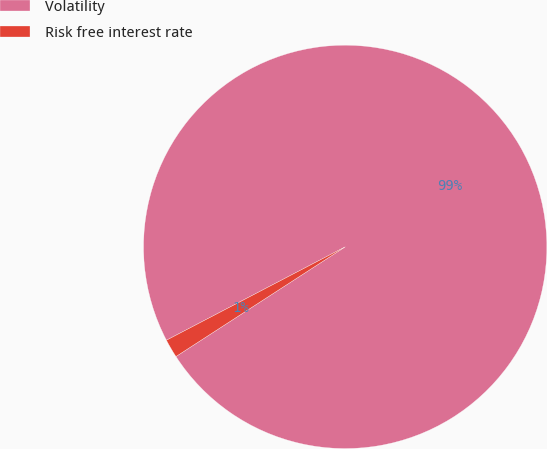<chart> <loc_0><loc_0><loc_500><loc_500><pie_chart><fcel>Volatility<fcel>Risk free interest rate<nl><fcel>98.51%<fcel>1.49%<nl></chart> 